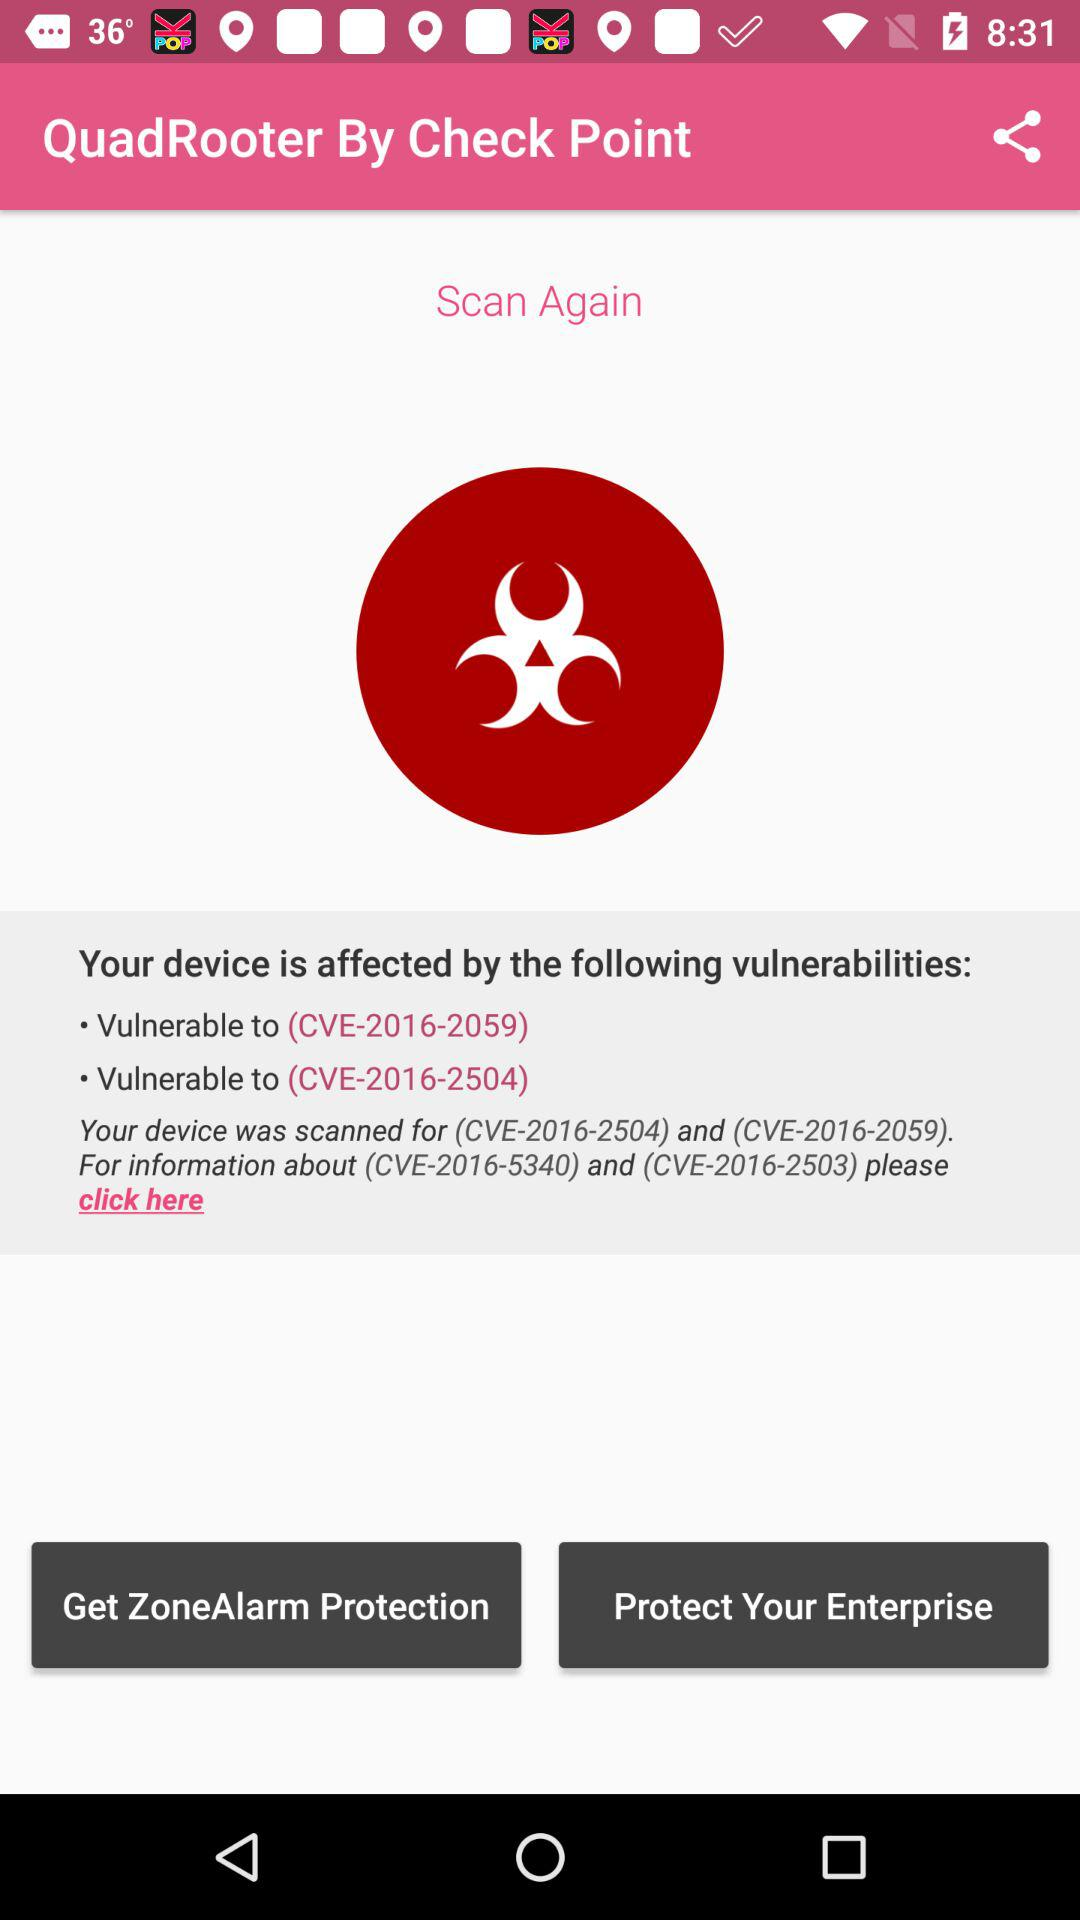What are the vulnerabilities that have affected my device? The vulnerabilities that have affected my device are "CVE-2016-2059" and "CVE-2016-2504". 